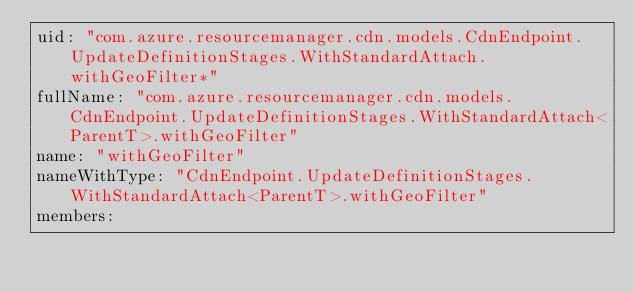Convert code to text. <code><loc_0><loc_0><loc_500><loc_500><_YAML_>uid: "com.azure.resourcemanager.cdn.models.CdnEndpoint.UpdateDefinitionStages.WithStandardAttach.withGeoFilter*"
fullName: "com.azure.resourcemanager.cdn.models.CdnEndpoint.UpdateDefinitionStages.WithStandardAttach<ParentT>.withGeoFilter"
name: "withGeoFilter"
nameWithType: "CdnEndpoint.UpdateDefinitionStages.WithStandardAttach<ParentT>.withGeoFilter"
members:</code> 